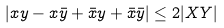Convert formula to latex. <formula><loc_0><loc_0><loc_500><loc_500>| x y - x \bar { y } + \bar { x } y + \bar { x } \bar { y } | \leq 2 | X Y |</formula> 